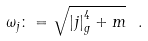Convert formula to latex. <formula><loc_0><loc_0><loc_500><loc_500>\omega _ { j } \colon = \sqrt { \left | j \right | ^ { 4 } _ { g } + m } \ .</formula> 